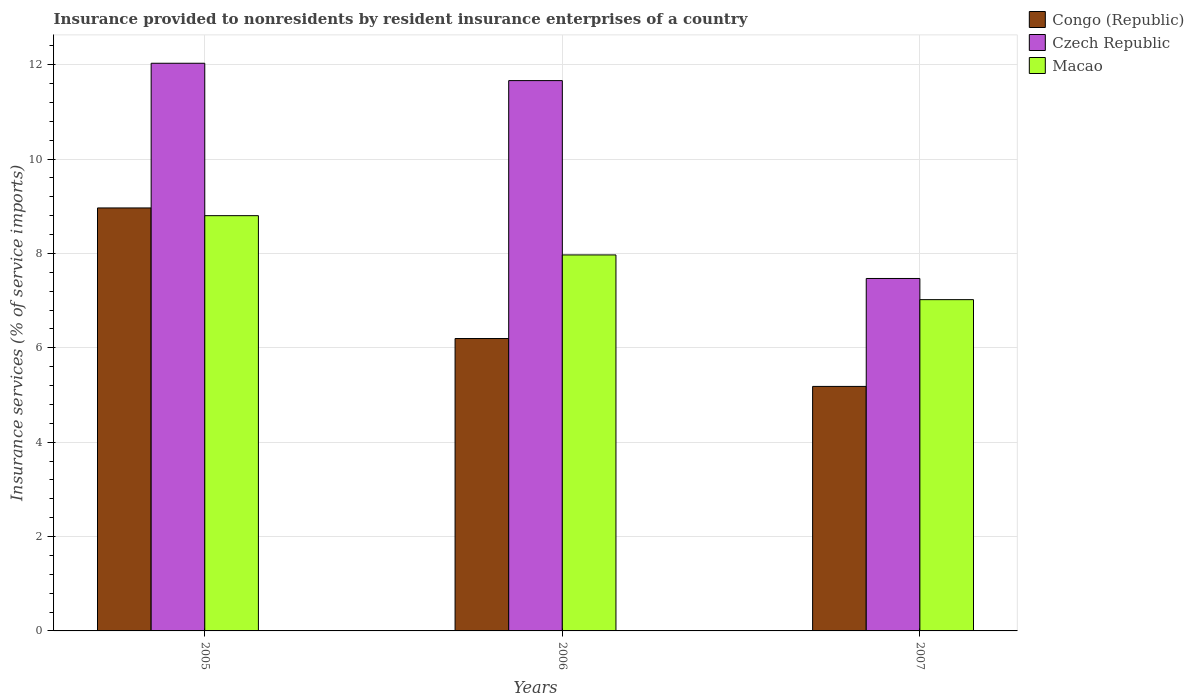How many different coloured bars are there?
Your answer should be compact. 3. Are the number of bars on each tick of the X-axis equal?
Your answer should be compact. Yes. How many bars are there on the 3rd tick from the right?
Make the answer very short. 3. What is the label of the 2nd group of bars from the left?
Offer a terse response. 2006. What is the insurance provided to nonresidents in Congo (Republic) in 2005?
Keep it short and to the point. 8.96. Across all years, what is the maximum insurance provided to nonresidents in Congo (Republic)?
Your answer should be compact. 8.96. Across all years, what is the minimum insurance provided to nonresidents in Czech Republic?
Make the answer very short. 7.47. What is the total insurance provided to nonresidents in Congo (Republic) in the graph?
Your answer should be compact. 20.34. What is the difference between the insurance provided to nonresidents in Congo (Republic) in 2005 and that in 2007?
Offer a terse response. 3.78. What is the difference between the insurance provided to nonresidents in Czech Republic in 2005 and the insurance provided to nonresidents in Macao in 2006?
Make the answer very short. 4.06. What is the average insurance provided to nonresidents in Congo (Republic) per year?
Provide a succinct answer. 6.78. In the year 2007, what is the difference between the insurance provided to nonresidents in Congo (Republic) and insurance provided to nonresidents in Czech Republic?
Your answer should be compact. -2.29. What is the ratio of the insurance provided to nonresidents in Czech Republic in 2005 to that in 2006?
Keep it short and to the point. 1.03. What is the difference between the highest and the second highest insurance provided to nonresidents in Macao?
Your response must be concise. 0.83. What is the difference between the highest and the lowest insurance provided to nonresidents in Congo (Republic)?
Offer a terse response. 3.78. What does the 3rd bar from the left in 2006 represents?
Make the answer very short. Macao. What does the 1st bar from the right in 2006 represents?
Keep it short and to the point. Macao. How many bars are there?
Keep it short and to the point. 9. Are the values on the major ticks of Y-axis written in scientific E-notation?
Give a very brief answer. No. Where does the legend appear in the graph?
Your answer should be very brief. Top right. How are the legend labels stacked?
Make the answer very short. Vertical. What is the title of the graph?
Keep it short and to the point. Insurance provided to nonresidents by resident insurance enterprises of a country. What is the label or title of the Y-axis?
Keep it short and to the point. Insurance services (% of service imports). What is the Insurance services (% of service imports) of Congo (Republic) in 2005?
Your answer should be very brief. 8.96. What is the Insurance services (% of service imports) in Czech Republic in 2005?
Offer a very short reply. 12.03. What is the Insurance services (% of service imports) in Macao in 2005?
Your response must be concise. 8.8. What is the Insurance services (% of service imports) in Congo (Republic) in 2006?
Ensure brevity in your answer.  6.2. What is the Insurance services (% of service imports) in Czech Republic in 2006?
Offer a terse response. 11.66. What is the Insurance services (% of service imports) of Macao in 2006?
Ensure brevity in your answer.  7.97. What is the Insurance services (% of service imports) in Congo (Republic) in 2007?
Provide a succinct answer. 5.18. What is the Insurance services (% of service imports) in Czech Republic in 2007?
Keep it short and to the point. 7.47. What is the Insurance services (% of service imports) in Macao in 2007?
Ensure brevity in your answer.  7.02. Across all years, what is the maximum Insurance services (% of service imports) in Congo (Republic)?
Ensure brevity in your answer.  8.96. Across all years, what is the maximum Insurance services (% of service imports) in Czech Republic?
Ensure brevity in your answer.  12.03. Across all years, what is the maximum Insurance services (% of service imports) of Macao?
Give a very brief answer. 8.8. Across all years, what is the minimum Insurance services (% of service imports) in Congo (Republic)?
Make the answer very short. 5.18. Across all years, what is the minimum Insurance services (% of service imports) in Czech Republic?
Ensure brevity in your answer.  7.47. Across all years, what is the minimum Insurance services (% of service imports) of Macao?
Your answer should be compact. 7.02. What is the total Insurance services (% of service imports) of Congo (Republic) in the graph?
Your answer should be very brief. 20.34. What is the total Insurance services (% of service imports) of Czech Republic in the graph?
Keep it short and to the point. 31.16. What is the total Insurance services (% of service imports) in Macao in the graph?
Ensure brevity in your answer.  23.79. What is the difference between the Insurance services (% of service imports) in Congo (Republic) in 2005 and that in 2006?
Provide a short and direct response. 2.77. What is the difference between the Insurance services (% of service imports) in Czech Republic in 2005 and that in 2006?
Your answer should be very brief. 0.37. What is the difference between the Insurance services (% of service imports) of Macao in 2005 and that in 2006?
Your answer should be very brief. 0.83. What is the difference between the Insurance services (% of service imports) of Congo (Republic) in 2005 and that in 2007?
Provide a short and direct response. 3.78. What is the difference between the Insurance services (% of service imports) in Czech Republic in 2005 and that in 2007?
Make the answer very short. 4.56. What is the difference between the Insurance services (% of service imports) in Macao in 2005 and that in 2007?
Your answer should be very brief. 1.78. What is the difference between the Insurance services (% of service imports) of Congo (Republic) in 2006 and that in 2007?
Keep it short and to the point. 1.01. What is the difference between the Insurance services (% of service imports) in Czech Republic in 2006 and that in 2007?
Ensure brevity in your answer.  4.19. What is the difference between the Insurance services (% of service imports) in Macao in 2006 and that in 2007?
Your response must be concise. 0.95. What is the difference between the Insurance services (% of service imports) in Congo (Republic) in 2005 and the Insurance services (% of service imports) in Czech Republic in 2006?
Your answer should be compact. -2.7. What is the difference between the Insurance services (% of service imports) in Czech Republic in 2005 and the Insurance services (% of service imports) in Macao in 2006?
Offer a very short reply. 4.06. What is the difference between the Insurance services (% of service imports) of Congo (Republic) in 2005 and the Insurance services (% of service imports) of Czech Republic in 2007?
Ensure brevity in your answer.  1.49. What is the difference between the Insurance services (% of service imports) of Congo (Republic) in 2005 and the Insurance services (% of service imports) of Macao in 2007?
Give a very brief answer. 1.94. What is the difference between the Insurance services (% of service imports) in Czech Republic in 2005 and the Insurance services (% of service imports) in Macao in 2007?
Ensure brevity in your answer.  5.01. What is the difference between the Insurance services (% of service imports) of Congo (Republic) in 2006 and the Insurance services (% of service imports) of Czech Republic in 2007?
Ensure brevity in your answer.  -1.27. What is the difference between the Insurance services (% of service imports) of Congo (Republic) in 2006 and the Insurance services (% of service imports) of Macao in 2007?
Offer a terse response. -0.82. What is the difference between the Insurance services (% of service imports) of Czech Republic in 2006 and the Insurance services (% of service imports) of Macao in 2007?
Provide a succinct answer. 4.64. What is the average Insurance services (% of service imports) of Congo (Republic) per year?
Make the answer very short. 6.78. What is the average Insurance services (% of service imports) in Czech Republic per year?
Your answer should be very brief. 10.39. What is the average Insurance services (% of service imports) in Macao per year?
Your answer should be very brief. 7.93. In the year 2005, what is the difference between the Insurance services (% of service imports) of Congo (Republic) and Insurance services (% of service imports) of Czech Republic?
Your response must be concise. -3.07. In the year 2005, what is the difference between the Insurance services (% of service imports) of Congo (Republic) and Insurance services (% of service imports) of Macao?
Offer a terse response. 0.16. In the year 2005, what is the difference between the Insurance services (% of service imports) of Czech Republic and Insurance services (% of service imports) of Macao?
Provide a succinct answer. 3.23. In the year 2006, what is the difference between the Insurance services (% of service imports) in Congo (Republic) and Insurance services (% of service imports) in Czech Republic?
Ensure brevity in your answer.  -5.47. In the year 2006, what is the difference between the Insurance services (% of service imports) in Congo (Republic) and Insurance services (% of service imports) in Macao?
Your answer should be compact. -1.77. In the year 2006, what is the difference between the Insurance services (% of service imports) in Czech Republic and Insurance services (% of service imports) in Macao?
Provide a succinct answer. 3.69. In the year 2007, what is the difference between the Insurance services (% of service imports) of Congo (Republic) and Insurance services (% of service imports) of Czech Republic?
Ensure brevity in your answer.  -2.29. In the year 2007, what is the difference between the Insurance services (% of service imports) of Congo (Republic) and Insurance services (% of service imports) of Macao?
Keep it short and to the point. -1.84. In the year 2007, what is the difference between the Insurance services (% of service imports) in Czech Republic and Insurance services (% of service imports) in Macao?
Keep it short and to the point. 0.45. What is the ratio of the Insurance services (% of service imports) in Congo (Republic) in 2005 to that in 2006?
Your response must be concise. 1.45. What is the ratio of the Insurance services (% of service imports) in Czech Republic in 2005 to that in 2006?
Provide a succinct answer. 1.03. What is the ratio of the Insurance services (% of service imports) of Macao in 2005 to that in 2006?
Give a very brief answer. 1.1. What is the ratio of the Insurance services (% of service imports) in Congo (Republic) in 2005 to that in 2007?
Provide a succinct answer. 1.73. What is the ratio of the Insurance services (% of service imports) in Czech Republic in 2005 to that in 2007?
Your response must be concise. 1.61. What is the ratio of the Insurance services (% of service imports) in Macao in 2005 to that in 2007?
Keep it short and to the point. 1.25. What is the ratio of the Insurance services (% of service imports) of Congo (Republic) in 2006 to that in 2007?
Give a very brief answer. 1.2. What is the ratio of the Insurance services (% of service imports) of Czech Republic in 2006 to that in 2007?
Provide a short and direct response. 1.56. What is the ratio of the Insurance services (% of service imports) of Macao in 2006 to that in 2007?
Provide a succinct answer. 1.14. What is the difference between the highest and the second highest Insurance services (% of service imports) in Congo (Republic)?
Your answer should be compact. 2.77. What is the difference between the highest and the second highest Insurance services (% of service imports) of Czech Republic?
Ensure brevity in your answer.  0.37. What is the difference between the highest and the second highest Insurance services (% of service imports) of Macao?
Provide a short and direct response. 0.83. What is the difference between the highest and the lowest Insurance services (% of service imports) in Congo (Republic)?
Your answer should be compact. 3.78. What is the difference between the highest and the lowest Insurance services (% of service imports) in Czech Republic?
Offer a terse response. 4.56. What is the difference between the highest and the lowest Insurance services (% of service imports) in Macao?
Ensure brevity in your answer.  1.78. 